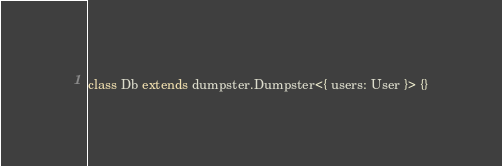<code> <loc_0><loc_0><loc_500><loc_500><_Haxe_>class Db extends dumpster.Dumpster<{ users: User }> {}</code> 